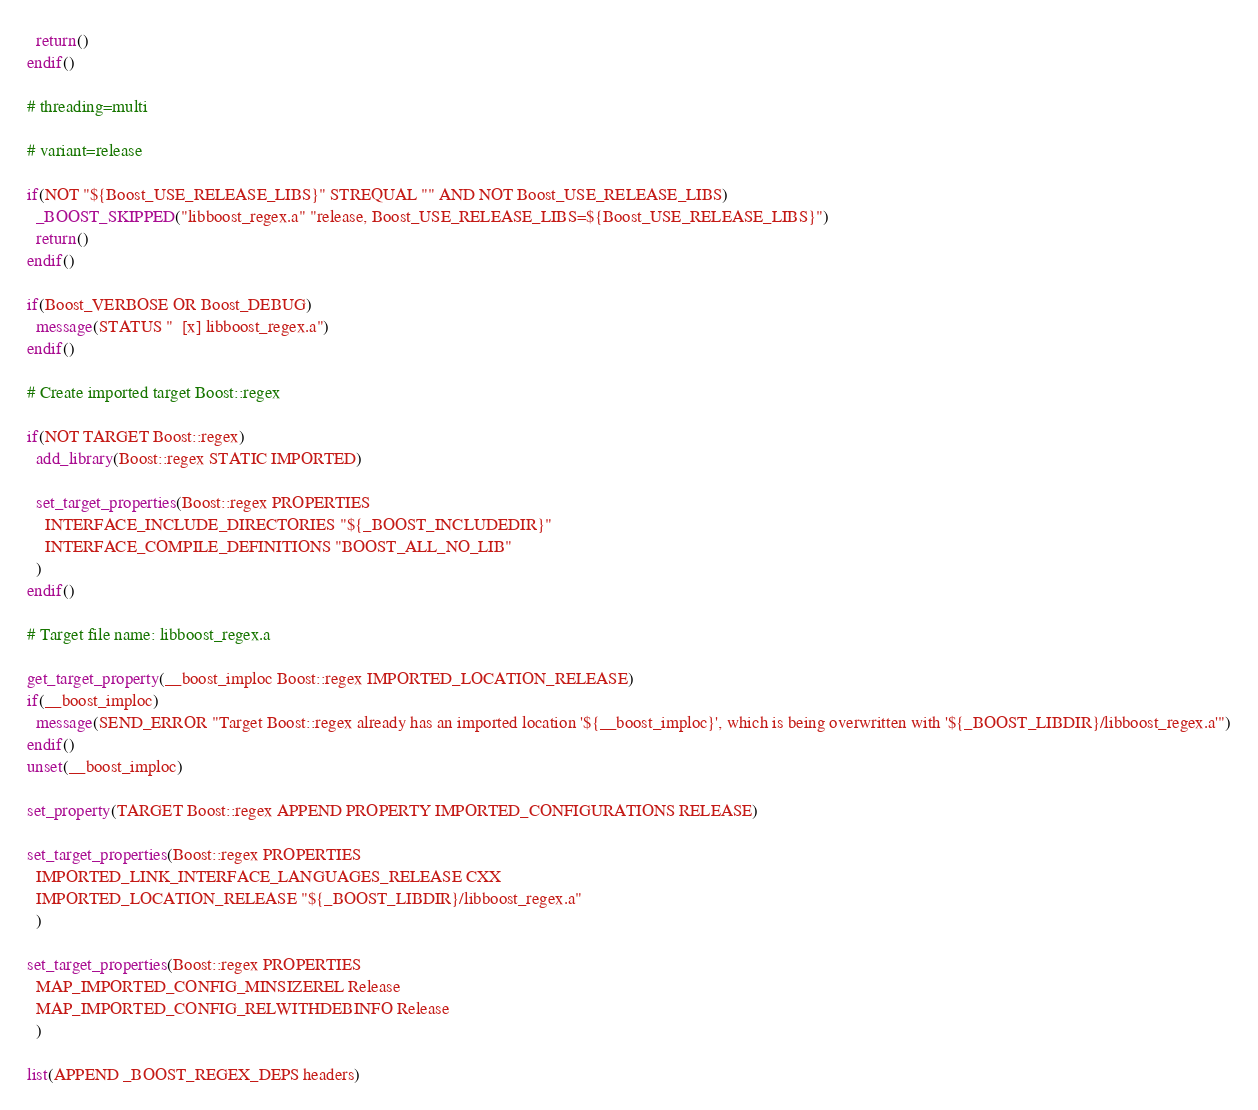<code> <loc_0><loc_0><loc_500><loc_500><_CMake_>  return()
endif()

# threading=multi

# variant=release

if(NOT "${Boost_USE_RELEASE_LIBS}" STREQUAL "" AND NOT Boost_USE_RELEASE_LIBS)
  _BOOST_SKIPPED("libboost_regex.a" "release, Boost_USE_RELEASE_LIBS=${Boost_USE_RELEASE_LIBS}")
  return()
endif()

if(Boost_VERBOSE OR Boost_DEBUG)
  message(STATUS "  [x] libboost_regex.a")
endif()

# Create imported target Boost::regex

if(NOT TARGET Boost::regex)
  add_library(Boost::regex STATIC IMPORTED)

  set_target_properties(Boost::regex PROPERTIES
    INTERFACE_INCLUDE_DIRECTORIES "${_BOOST_INCLUDEDIR}"
    INTERFACE_COMPILE_DEFINITIONS "BOOST_ALL_NO_LIB"
  )
endif()

# Target file name: libboost_regex.a

get_target_property(__boost_imploc Boost::regex IMPORTED_LOCATION_RELEASE)
if(__boost_imploc)
  message(SEND_ERROR "Target Boost::regex already has an imported location '${__boost_imploc}', which is being overwritten with '${_BOOST_LIBDIR}/libboost_regex.a'")
endif()
unset(__boost_imploc)

set_property(TARGET Boost::regex APPEND PROPERTY IMPORTED_CONFIGURATIONS RELEASE)

set_target_properties(Boost::regex PROPERTIES
  IMPORTED_LINK_INTERFACE_LANGUAGES_RELEASE CXX
  IMPORTED_LOCATION_RELEASE "${_BOOST_LIBDIR}/libboost_regex.a"
  )

set_target_properties(Boost::regex PROPERTIES
  MAP_IMPORTED_CONFIG_MINSIZEREL Release
  MAP_IMPORTED_CONFIG_RELWITHDEBINFO Release
  )

list(APPEND _BOOST_REGEX_DEPS headers)
</code> 